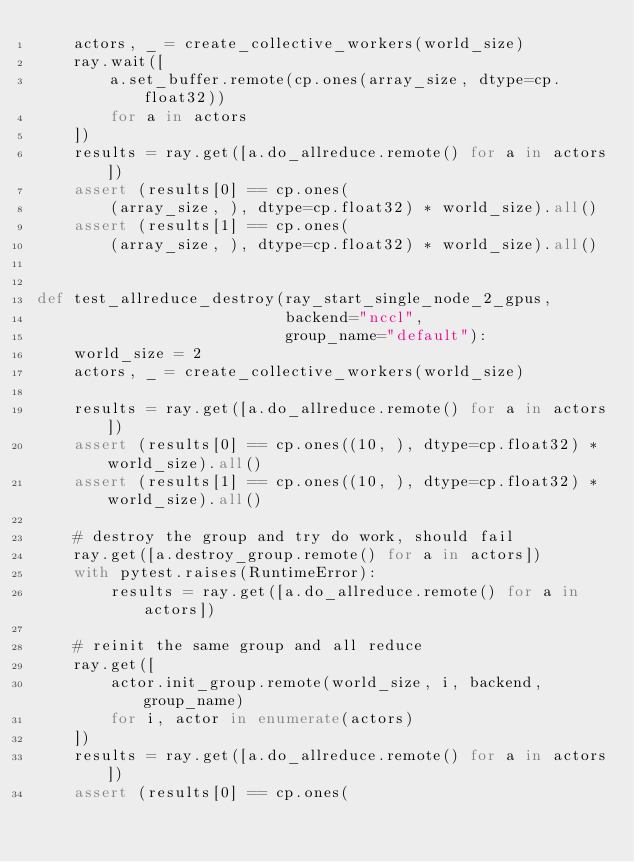Convert code to text. <code><loc_0><loc_0><loc_500><loc_500><_Python_>    actors, _ = create_collective_workers(world_size)
    ray.wait([
        a.set_buffer.remote(cp.ones(array_size, dtype=cp.float32))
        for a in actors
    ])
    results = ray.get([a.do_allreduce.remote() for a in actors])
    assert (results[0] == cp.ones(
        (array_size, ), dtype=cp.float32) * world_size).all()
    assert (results[1] == cp.ones(
        (array_size, ), dtype=cp.float32) * world_size).all()


def test_allreduce_destroy(ray_start_single_node_2_gpus,
                           backend="nccl",
                           group_name="default"):
    world_size = 2
    actors, _ = create_collective_workers(world_size)

    results = ray.get([a.do_allreduce.remote() for a in actors])
    assert (results[0] == cp.ones((10, ), dtype=cp.float32) * world_size).all()
    assert (results[1] == cp.ones((10, ), dtype=cp.float32) * world_size).all()

    # destroy the group and try do work, should fail
    ray.get([a.destroy_group.remote() for a in actors])
    with pytest.raises(RuntimeError):
        results = ray.get([a.do_allreduce.remote() for a in actors])

    # reinit the same group and all reduce
    ray.get([
        actor.init_group.remote(world_size, i, backend, group_name)
        for i, actor in enumerate(actors)
    ])
    results = ray.get([a.do_allreduce.remote() for a in actors])
    assert (results[0] == cp.ones(</code> 